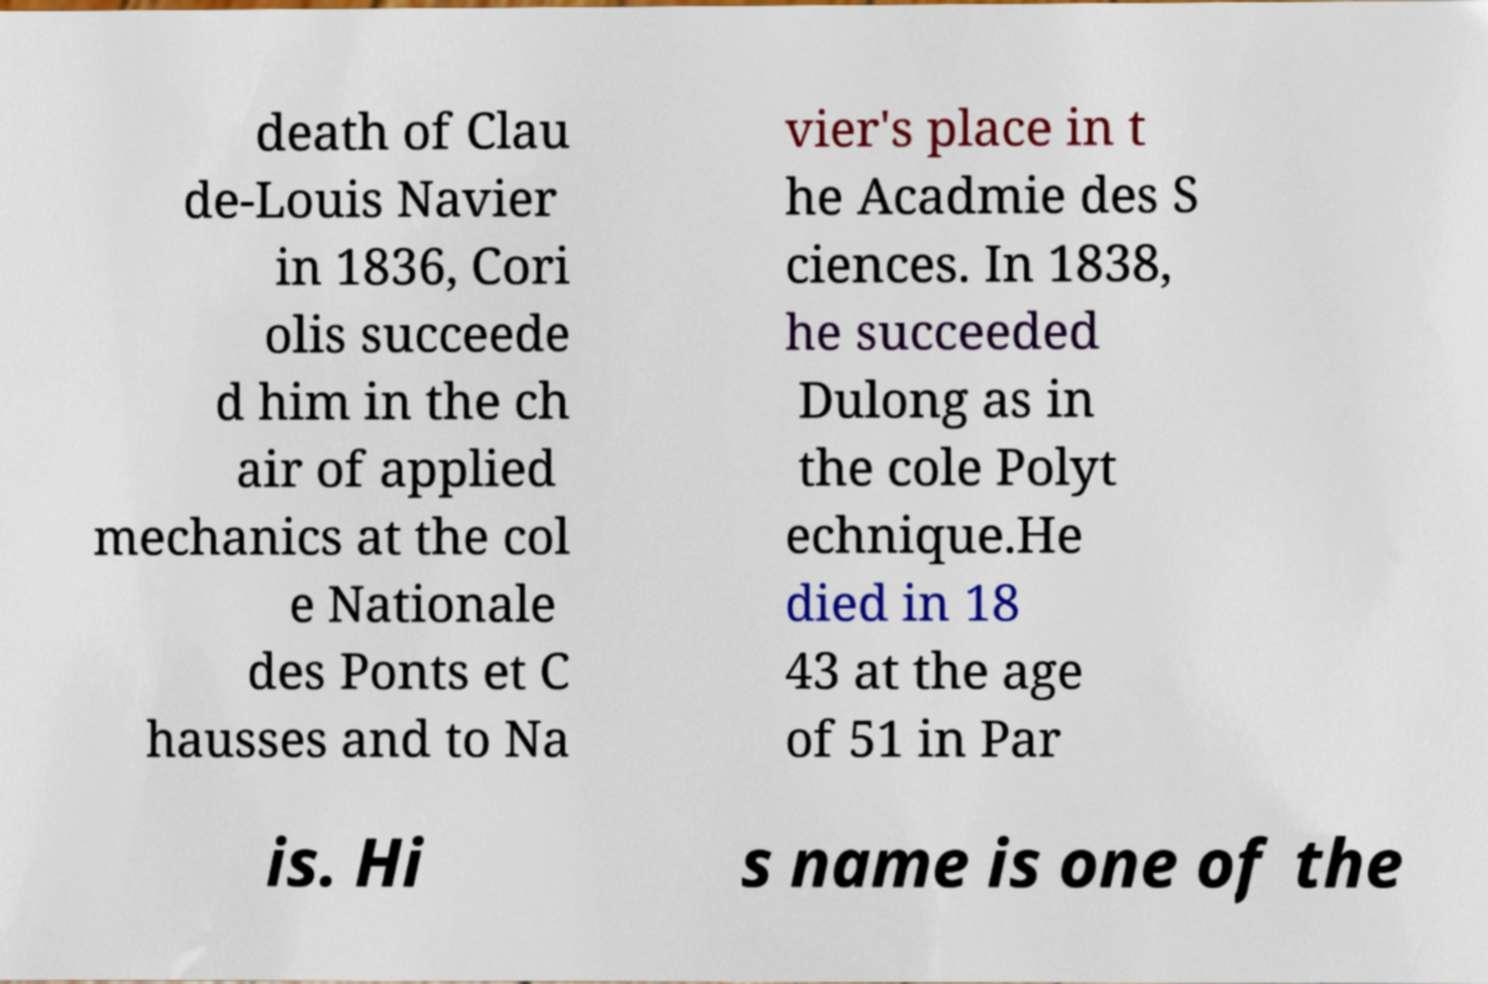Could you extract and type out the text from this image? death of Clau de-Louis Navier in 1836, Cori olis succeede d him in the ch air of applied mechanics at the col e Nationale des Ponts et C hausses and to Na vier's place in t he Acadmie des S ciences. In 1838, he succeeded Dulong as in the cole Polyt echnique.He died in 18 43 at the age of 51 in Par is. Hi s name is one of the 